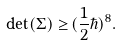<formula> <loc_0><loc_0><loc_500><loc_500>\det ( \Sigma ) \geq & \, ( { \frac { 1 } { 2 } } \hbar { ) } ^ { 8 } .</formula> 